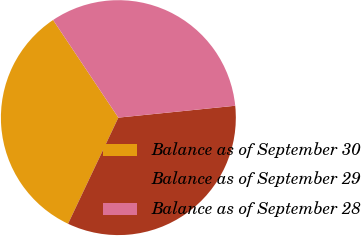Convert chart to OTSL. <chart><loc_0><loc_0><loc_500><loc_500><pie_chart><fcel>Balance as of September 30<fcel>Balance as of September 29<fcel>Balance as of September 28<nl><fcel>33.58%<fcel>33.66%<fcel>32.77%<nl></chart> 